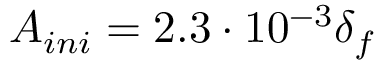<formula> <loc_0><loc_0><loc_500><loc_500>A _ { i n i } = 2 . 3 \cdot 1 0 ^ { - 3 } \delta _ { f }</formula> 